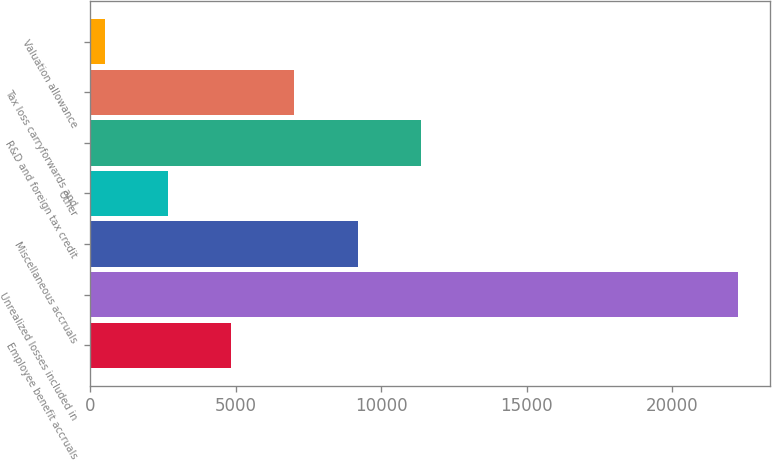Convert chart. <chart><loc_0><loc_0><loc_500><loc_500><bar_chart><fcel>Employee benefit accruals<fcel>Unrealized losses included in<fcel>Miscellaneous accruals<fcel>Other<fcel>R&D and foreign tax credit<fcel>Tax loss carryforwards and<fcel>Valuation allowance<nl><fcel>4837.8<fcel>22249<fcel>9190.6<fcel>2661.4<fcel>11367<fcel>7014.2<fcel>485<nl></chart> 